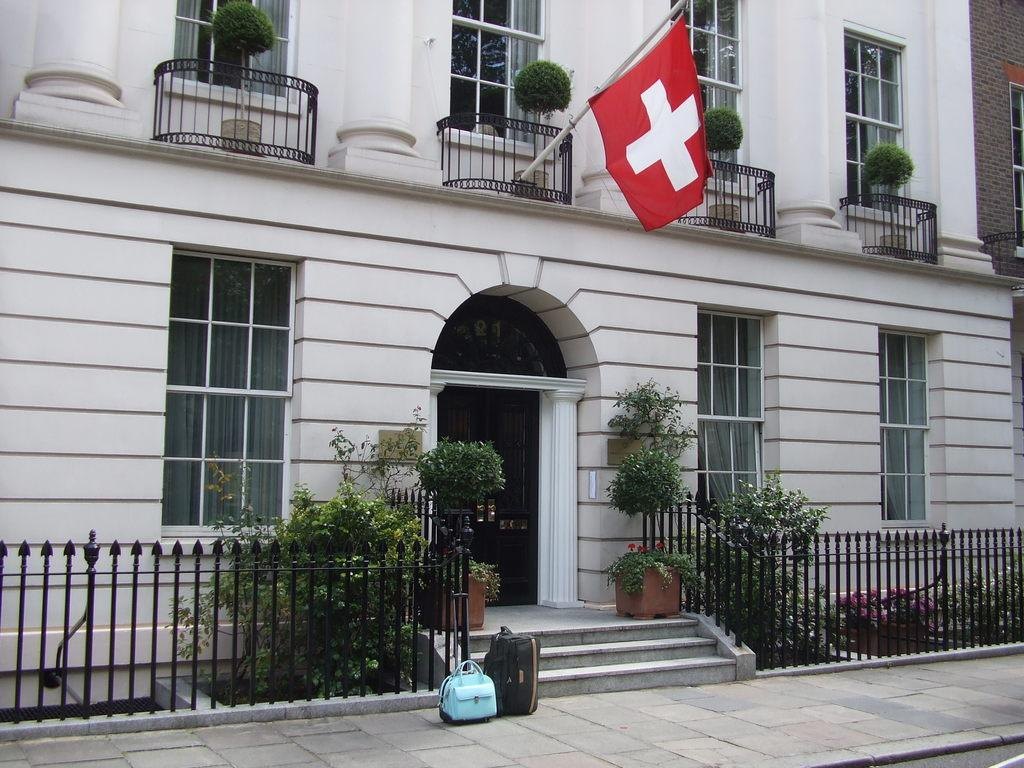What type of structure is visible in the image? There is a building in the image. What can be seen on the building in the image? There are windows visible on the building. What other elements are present in the image? There are plants, a flag, and a fence in the image. What type of glove is being used to stitch the flag in the image? There is no glove or stitching activity present in the image. 